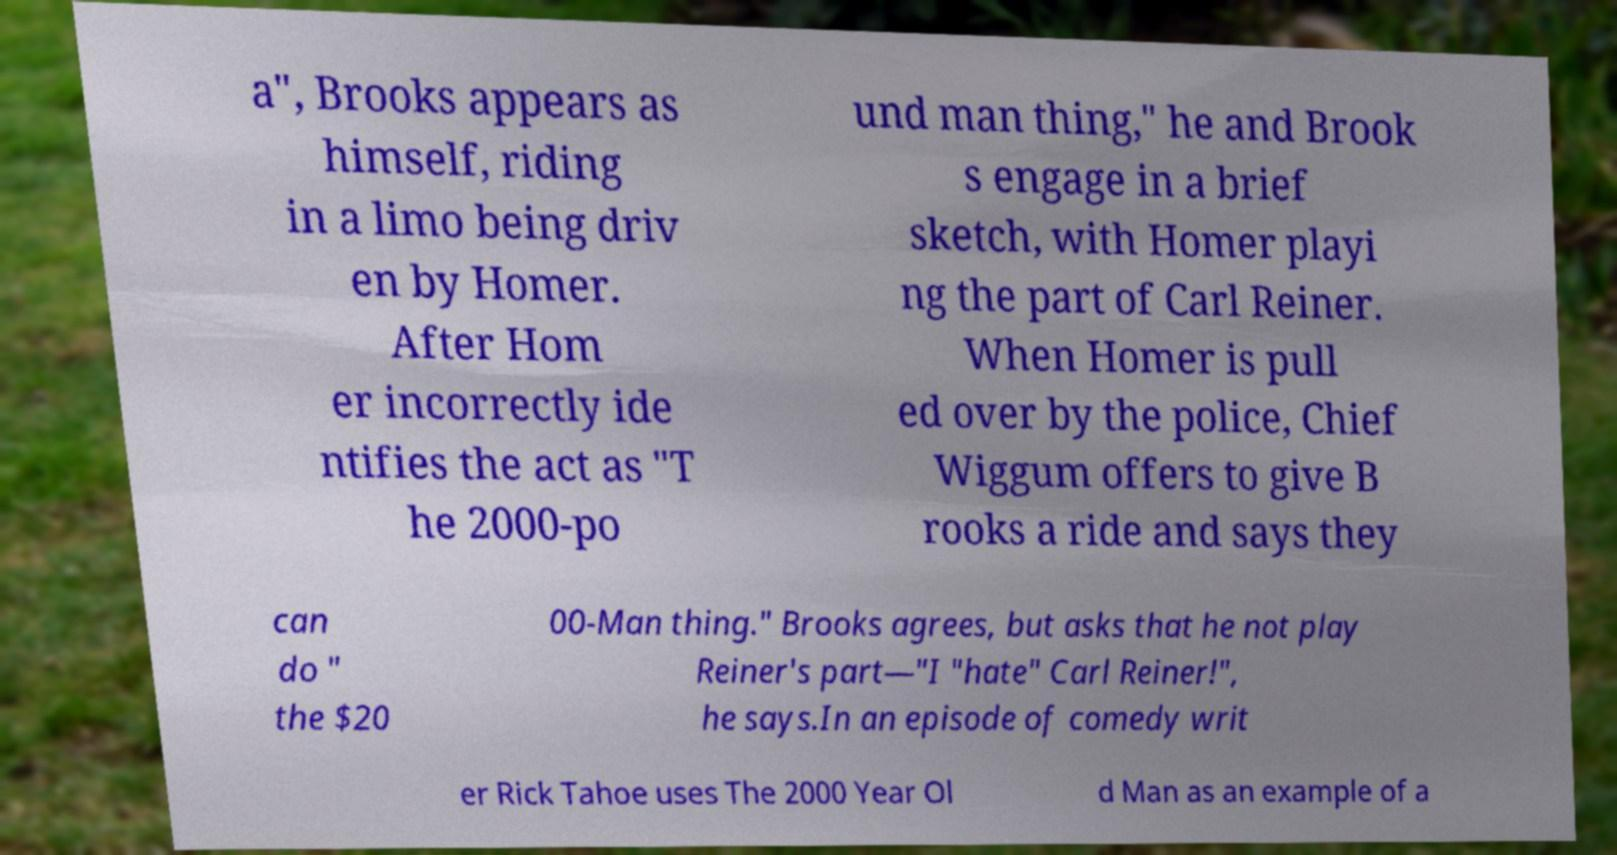Please read and relay the text visible in this image. What does it say? a", Brooks appears as himself, riding in a limo being driv en by Homer. After Hom er incorrectly ide ntifies the act as "T he 2000-po und man thing," he and Brook s engage in a brief sketch, with Homer playi ng the part of Carl Reiner. When Homer is pull ed over by the police, Chief Wiggum offers to give B rooks a ride and says they can do " the $20 00-Man thing." Brooks agrees, but asks that he not play Reiner's part—"I "hate" Carl Reiner!", he says.In an episode of comedy writ er Rick Tahoe uses The 2000 Year Ol d Man as an example of a 